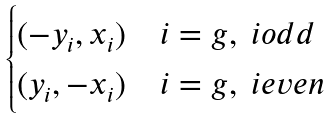<formula> <loc_0><loc_0><loc_500><loc_500>\begin{cases} ( - y _ { i } , x _ { i } ) & i = g , \ i o d d \\ ( y _ { i } , - x _ { i } ) & i = g , \ i e v e n \\ \end{cases}</formula> 